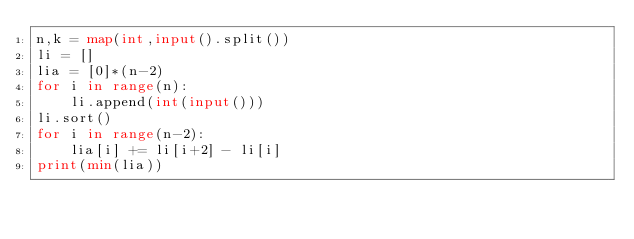Convert code to text. <code><loc_0><loc_0><loc_500><loc_500><_Python_>n,k = map(int,input().split())
li = []
lia = [0]*(n-2)
for i in range(n):
    li.append(int(input()))
li.sort()
for i in range(n-2):
    lia[i] += li[i+2] - li[i]
print(min(lia))</code> 